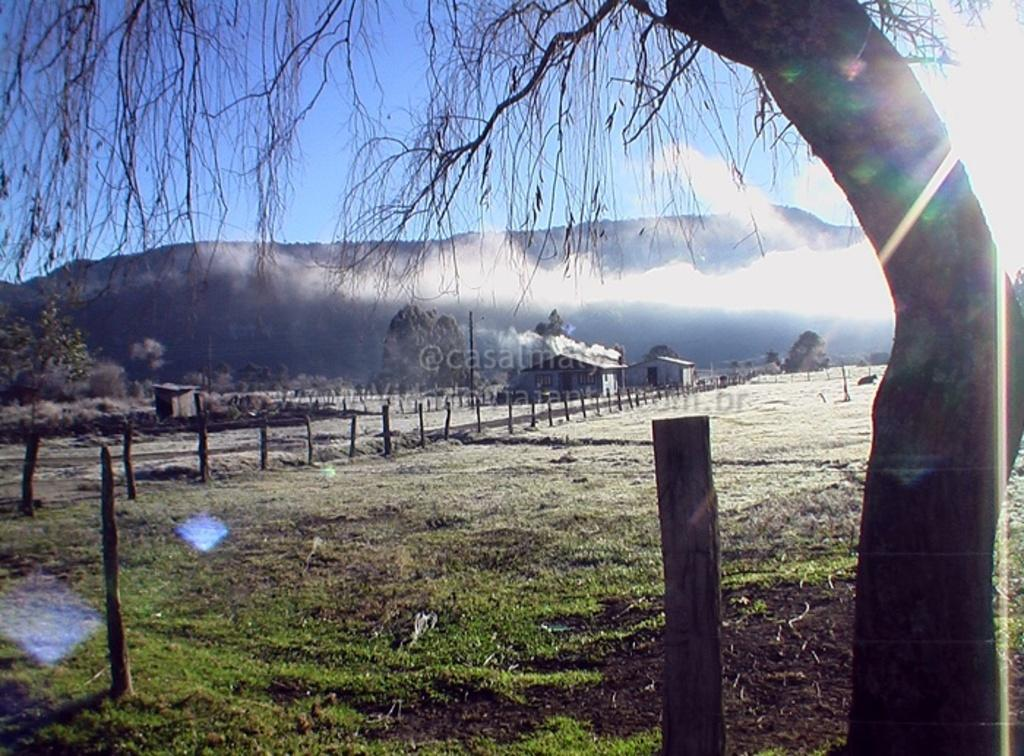What structures can be seen in the image? There are poles in the image. What type of vegetation is on the right side of the image? There is a tree on the right side of the image. What can be seen in the background of the image? There are houses, hills, and the sky visible in the background of the image. What type of beef is being served to the crowd in the image? There is no beef or crowd present in the image; it features poles, a tree, houses, hills, and the sky. 